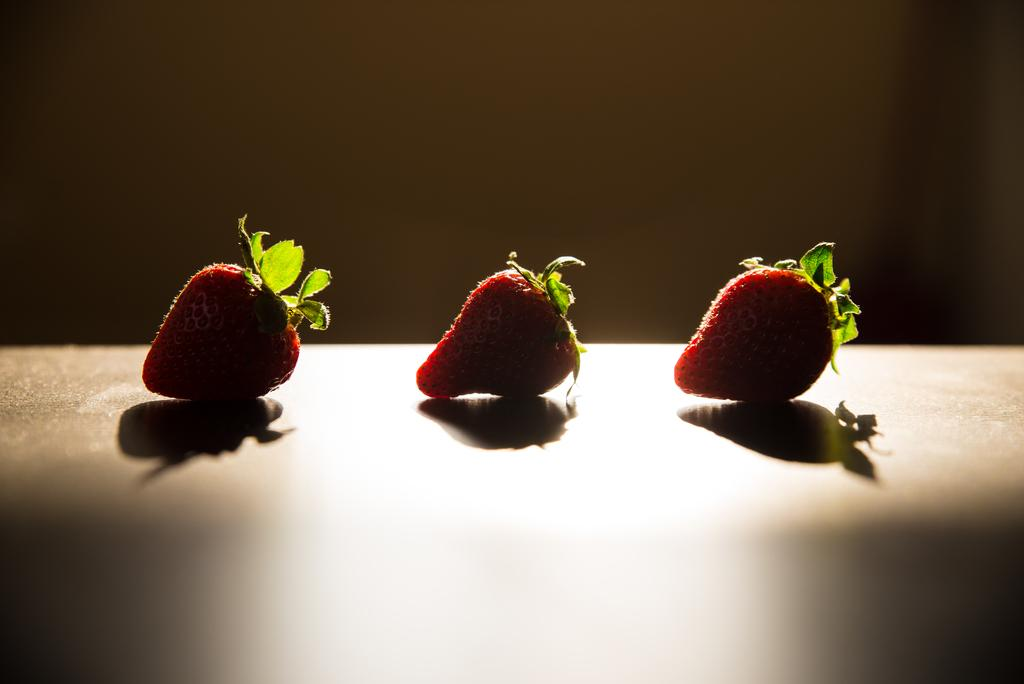How many strawberries are visible in the image? There are three strawberries in the image. Where are the strawberries placed in the image? The strawberries are placed on a surface in the image. What can be seen in the background of the image? There appears to be a wall in the background of the image. What is the condition of the sky in the image? There is no sky visible in the image; it only shows strawberries on a surface with a wall in the background. 